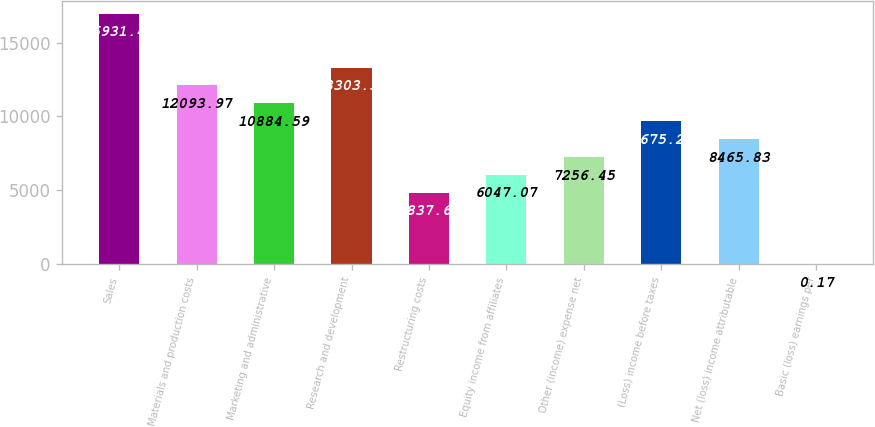<chart> <loc_0><loc_0><loc_500><loc_500><bar_chart><fcel>Sales<fcel>Materials and production costs<fcel>Marketing and administrative<fcel>Research and development<fcel>Restructuring costs<fcel>Equity income from affiliates<fcel>Other (income) expense net<fcel>(Loss) income before taxes<fcel>Net (loss) income attributable<fcel>Basic (loss) earnings per<nl><fcel>16931.5<fcel>12094<fcel>10884.6<fcel>13303.4<fcel>4837.69<fcel>6047.07<fcel>7256.45<fcel>9675.21<fcel>8465.83<fcel>0.17<nl></chart> 